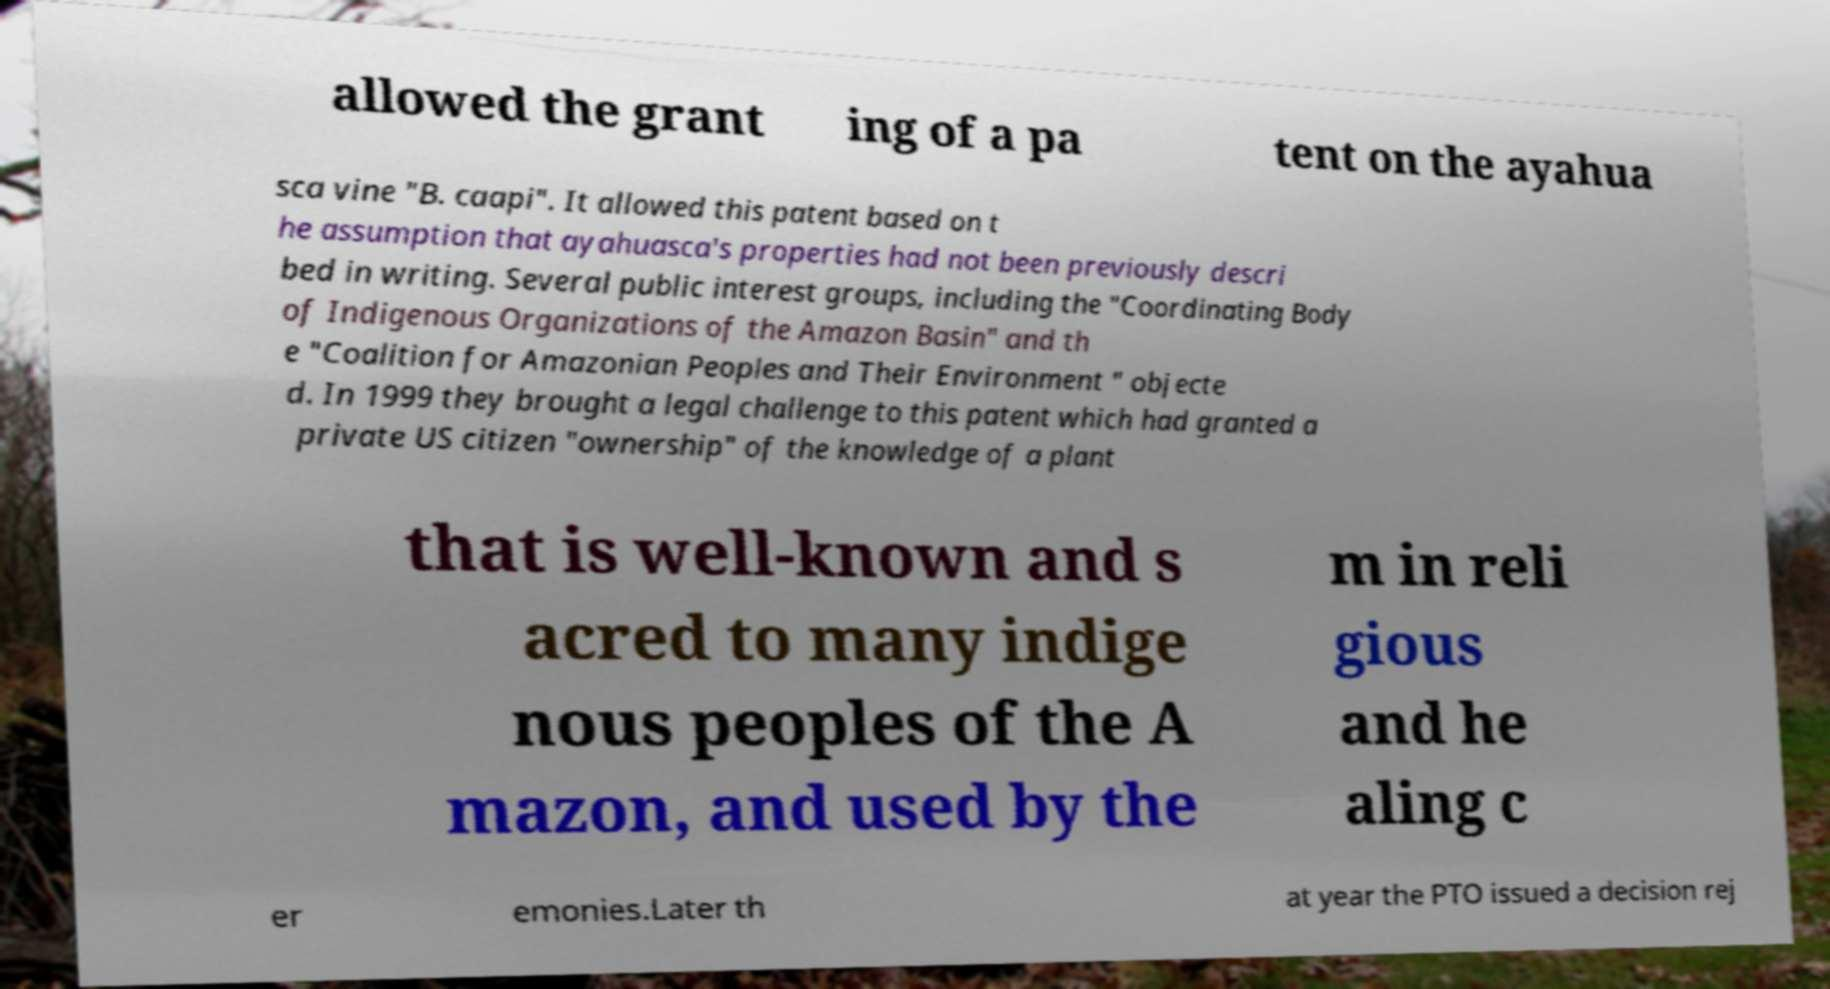Could you assist in decoding the text presented in this image and type it out clearly? allowed the grant ing of a pa tent on the ayahua sca vine "B. caapi". It allowed this patent based on t he assumption that ayahuasca's properties had not been previously descri bed in writing. Several public interest groups, including the "Coordinating Body of Indigenous Organizations of the Amazon Basin" and th e "Coalition for Amazonian Peoples and Their Environment " objecte d. In 1999 they brought a legal challenge to this patent which had granted a private US citizen "ownership" of the knowledge of a plant that is well-known and s acred to many indige nous peoples of the A mazon, and used by the m in reli gious and he aling c er emonies.Later th at year the PTO issued a decision rej 